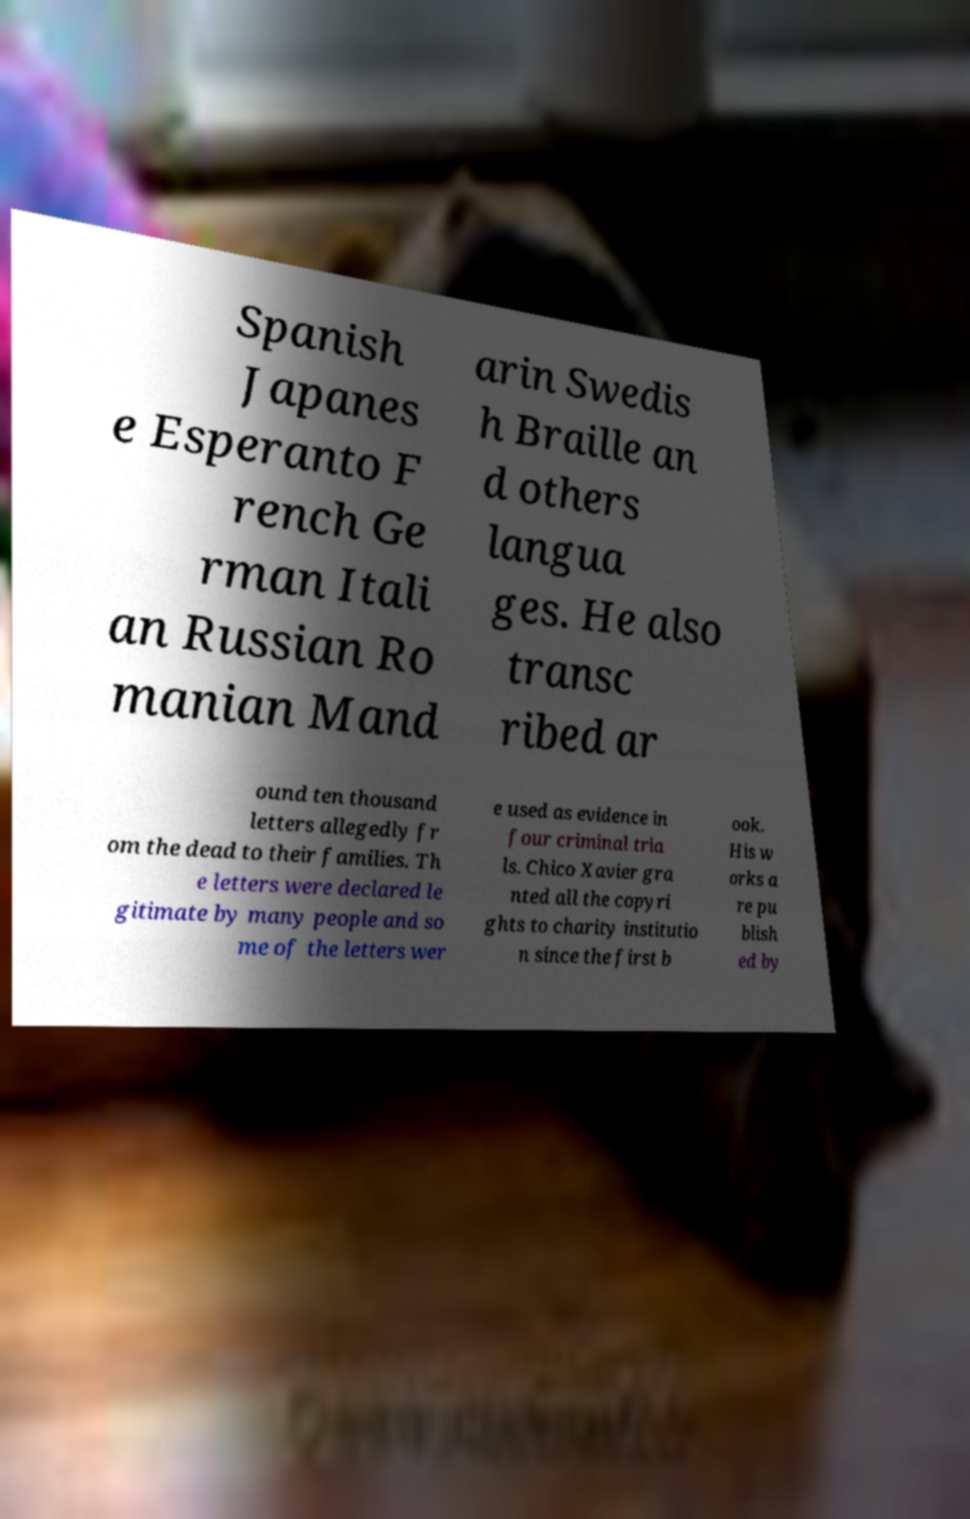Could you assist in decoding the text presented in this image and type it out clearly? Spanish Japanes e Esperanto F rench Ge rman Itali an Russian Ro manian Mand arin Swedis h Braille an d others langua ges. He also transc ribed ar ound ten thousand letters allegedly fr om the dead to their families. Th e letters were declared le gitimate by many people and so me of the letters wer e used as evidence in four criminal tria ls. Chico Xavier gra nted all the copyri ghts to charity institutio n since the first b ook. His w orks a re pu blish ed by 